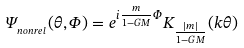<formula> <loc_0><loc_0><loc_500><loc_500>\Psi _ { _ { n o n r e l } } ( \theta , \Phi ) = e ^ { i \frac { m } { 1 - G M } \Phi } K _ { \frac { | m | } { 1 - G M } } ( k \theta )</formula> 